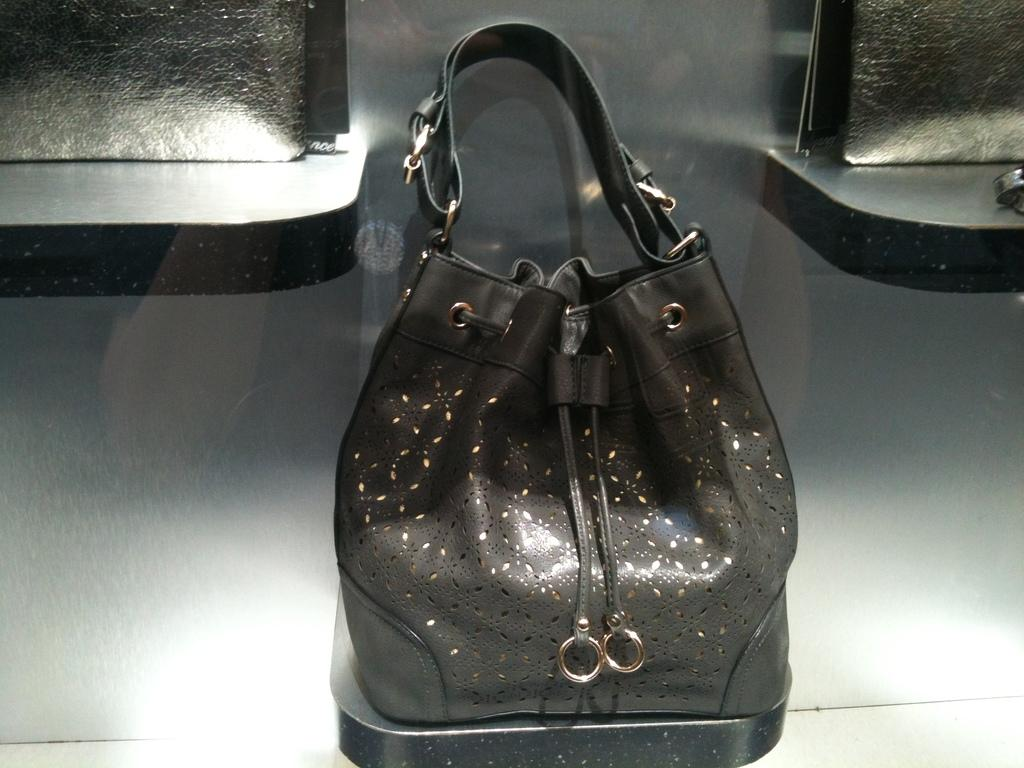What is the main object in the image? There is a black bag in the image. What can be seen behind the bag? The background of the bag is a glass. What type of activity is the expert performing in the image? There is no expert or activity present in the image; it only features a black bag with a glass background. 